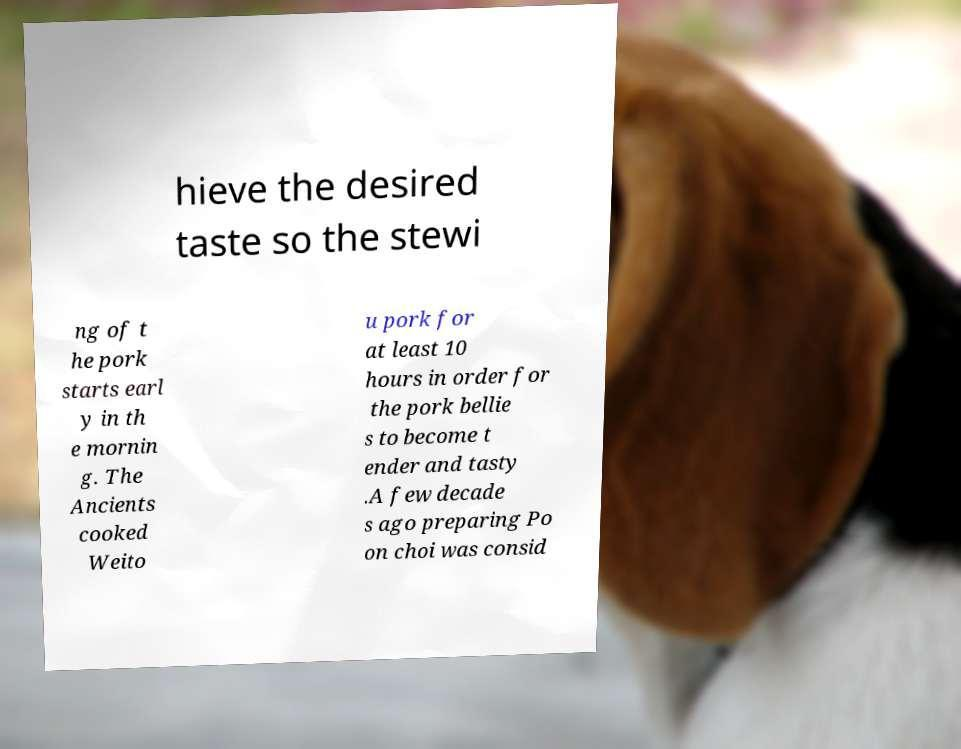Could you assist in decoding the text presented in this image and type it out clearly? hieve the desired taste so the stewi ng of t he pork starts earl y in th e mornin g. The Ancients cooked Weito u pork for at least 10 hours in order for the pork bellie s to become t ender and tasty .A few decade s ago preparing Po on choi was consid 